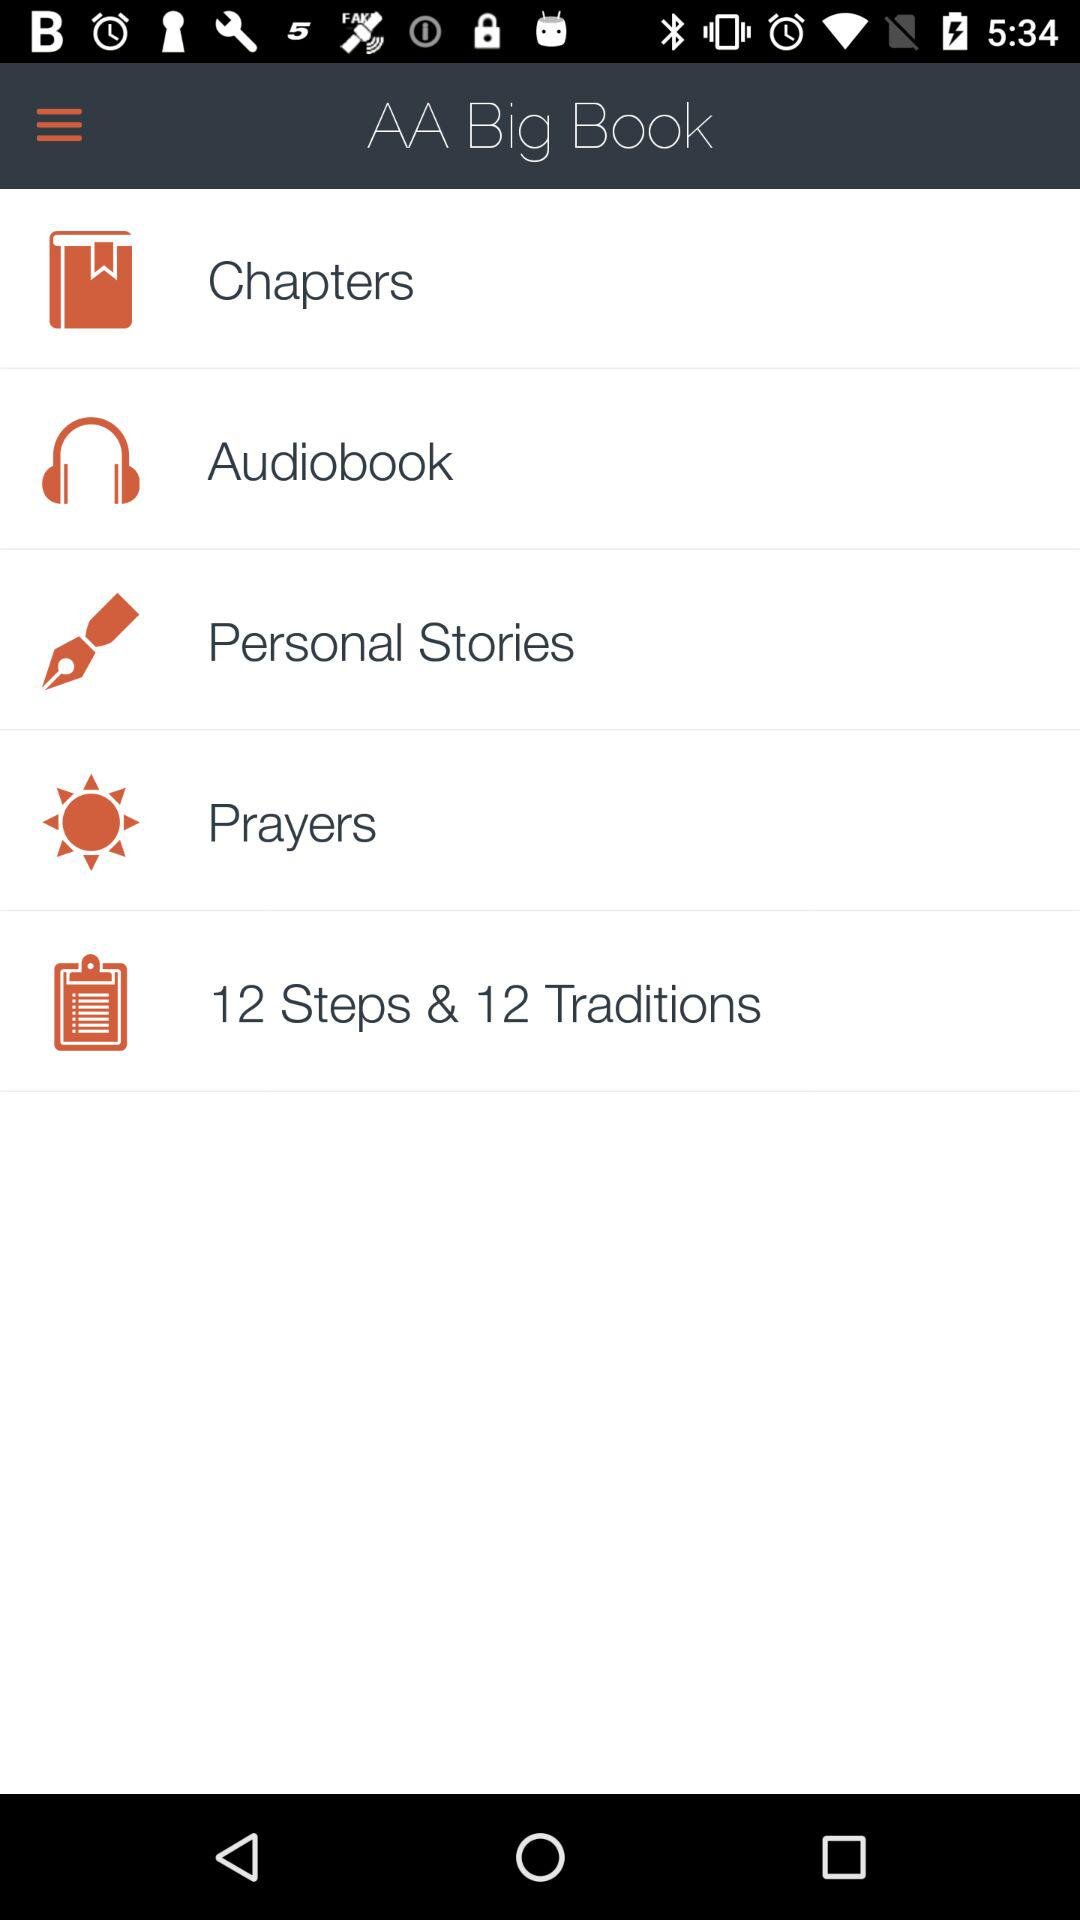What is the application name? The application name is "AA Big Book". 